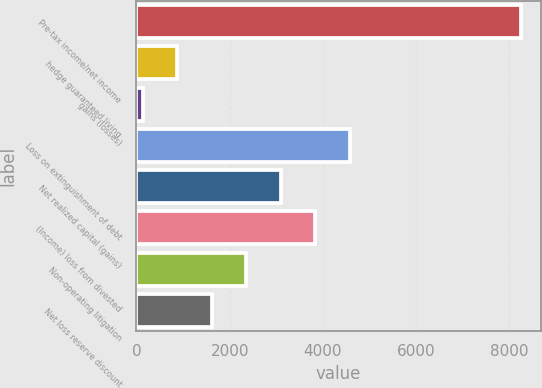Convert chart. <chart><loc_0><loc_0><loc_500><loc_500><bar_chart><fcel>Pre-tax income/net income<fcel>hedge guaranteed living<fcel>gains (losses)<fcel>Loss on extinguishment of debt<fcel>Net realized capital (gains)<fcel>(Income) loss from divested<fcel>Non-operating litigation<fcel>Net loss reserve discount<nl><fcel>8252.8<fcel>879.8<fcel>141<fcel>4573.8<fcel>3096.2<fcel>3835<fcel>2357.4<fcel>1618.6<nl></chart> 